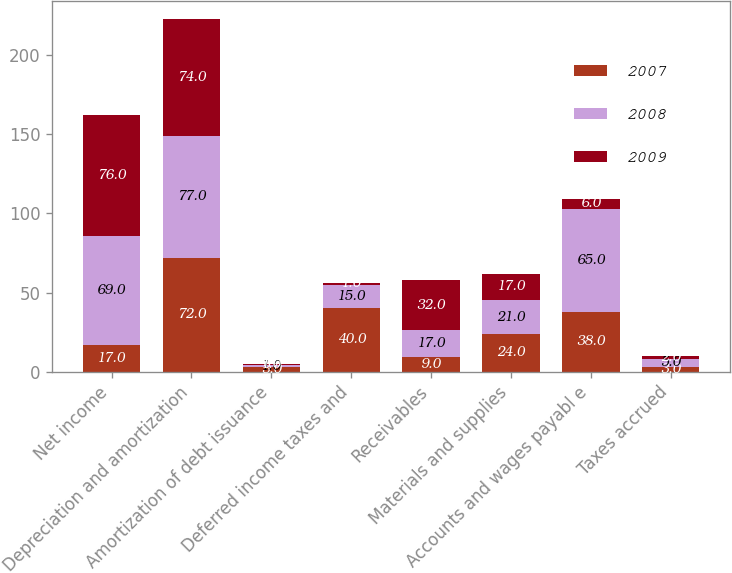Convert chart to OTSL. <chart><loc_0><loc_0><loc_500><loc_500><stacked_bar_chart><ecel><fcel>Net income<fcel>Depreciation and amortization<fcel>Amortization of debt issuance<fcel>Deferred income taxes and<fcel>Receivables<fcel>Materials and supplies<fcel>Accounts and wages payabl e<fcel>Taxes accrued<nl><fcel>2007<fcel>17<fcel>72<fcel>3<fcel>40<fcel>9<fcel>24<fcel>38<fcel>3<nl><fcel>2008<fcel>69<fcel>77<fcel>1<fcel>15<fcel>17<fcel>21<fcel>65<fcel>5<nl><fcel>2009<fcel>76<fcel>74<fcel>1<fcel>1<fcel>32<fcel>17<fcel>6<fcel>2<nl></chart> 